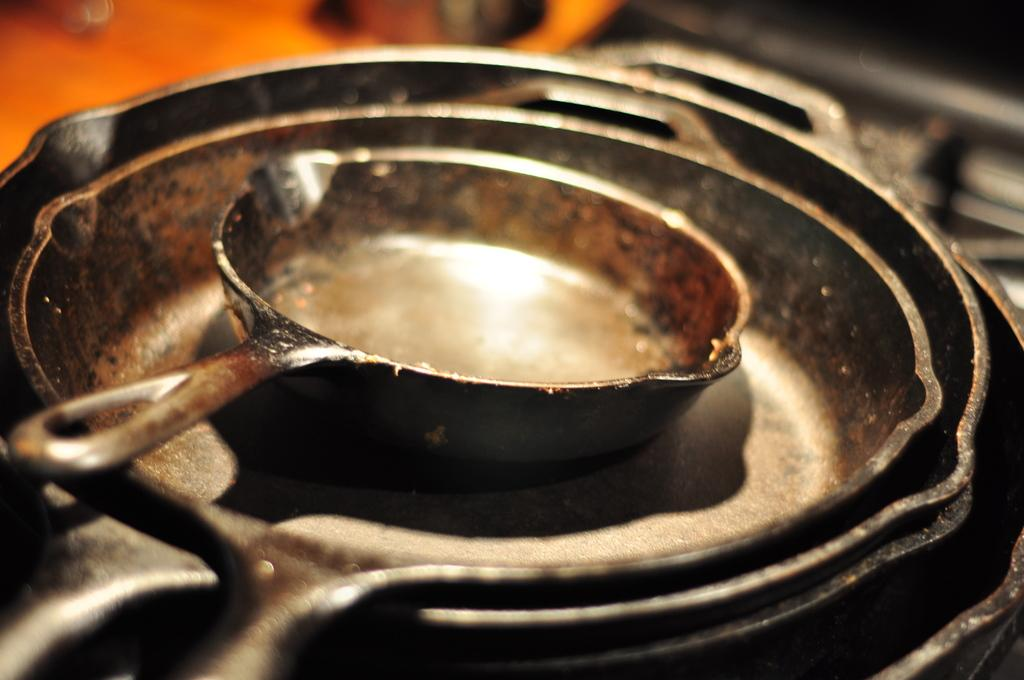What type of kitchenware is present in the image? There are pans in the image. Can you describe the background of the image? The background of the image is blurred. What color is the thumb in the image? There is no thumb present in the image. What emotion is the color in the image conveying? The image does not convey any emotions through color, as there is no color mentioned in the facts. 